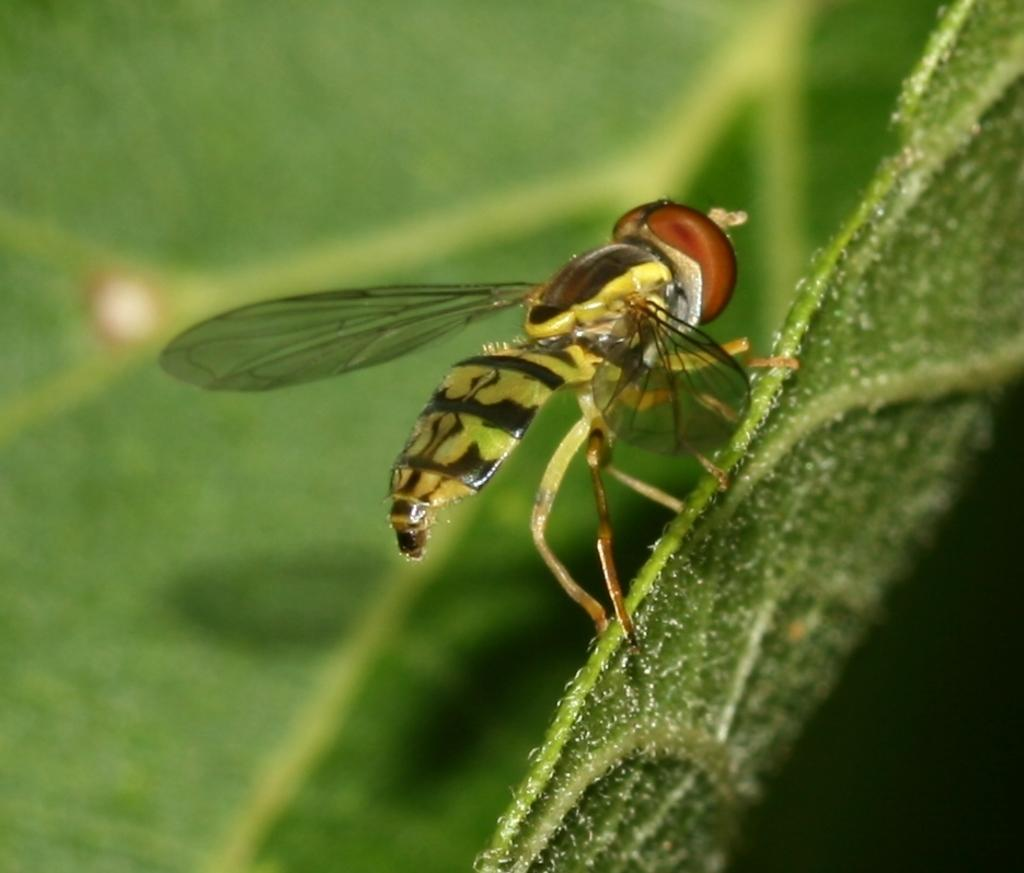Where was the image taken? The image was taken outdoors. What can be seen in the background of the image? There is a leaf in the background of the image. What is the color of the leaf? The leaf is green in color. Is there anything on the leaf in the image? Yes, there is a fly on the leaf in the image. What type of behavior does the fly exhibit in the image? The image does not show the fly's behavior, only its presence on the leaf. 